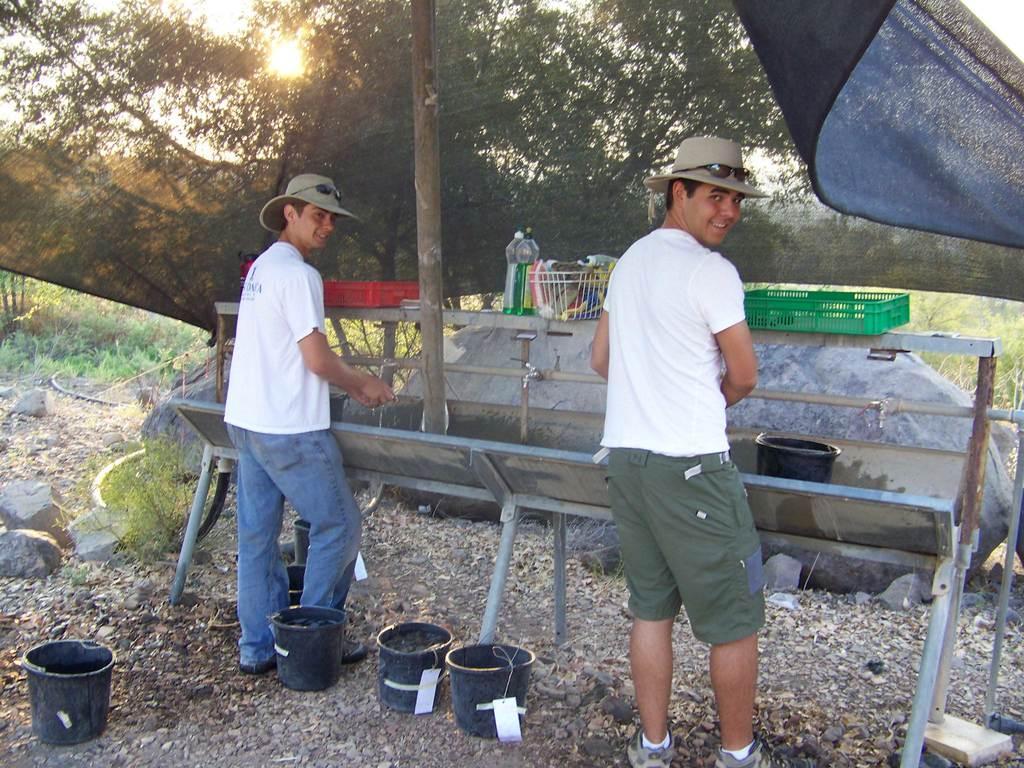Could you give a brief overview of what you see in this image? In this picture there are two boys wearing white color t-shirt and green short standing at the steel wash basin and giving a pose into the camera. Behind there is a green and red color basket and many trees in the background. In the front bottoms side there are three black buckets placed on the ground. 